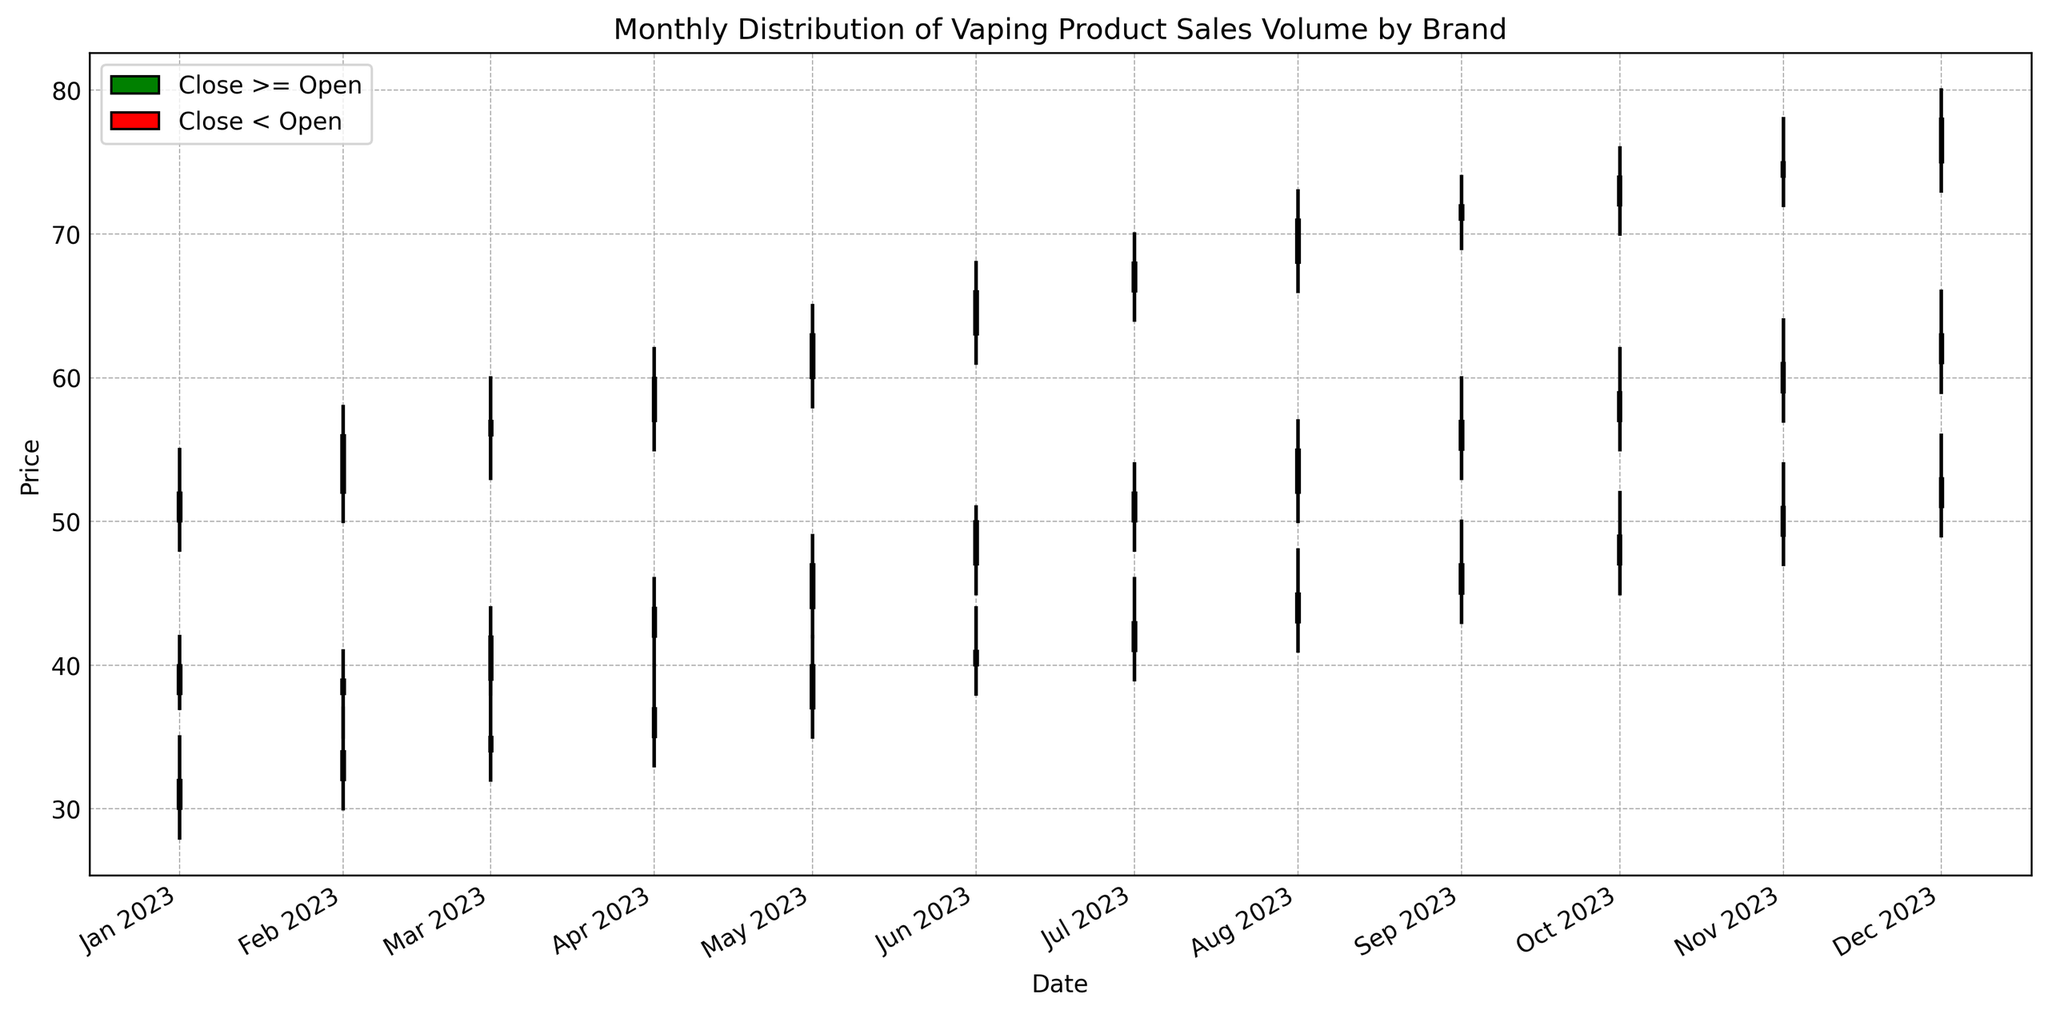What was the highest price achieved by Brand A in August 2023? In the candlestick chart, look for the high point in the candlestick for Brand A in August 2023. It is marked by the top of the wick
Answer: 73 Did Brand B's closing price ever fall and then rise again within the same month? To answer this, observe the color of the candlestick; if it is green, the closing price is higher than the opening price; if it is red, the closing price is lower. Brand B's candles are consistently green or red within each month, indicating no such fluctuations.
Answer: No Which brand saw the most consistent rise in their closing prices over the months? Consider the monthly closing prices of each brand and see which consistently increases. Brand A has a rising trend in closing prices each month throughout the year.
Answer: Brand A During which month did Brand C see the largest increase in their closing price from the previous month? By checking the difference in closing prices of Brand C across consecutive months, the largest increase is from 47 (May 2023) to 50 (June 2023).
Answer: June 2023 How many times did Brand B's closing price remain the same as its opening price? For the closing price to equal the opening price, the candle must be a horizontal line (neither green nor red). This does not visually occur for Brand B in any month.
Answer: 0 times Which brand had the highest sales volume in November 2023? By inspecting the text with the candlestick data, Brand A had the highest sales volume of 2500 in November 2023.
Answer: Brand A Compare the average closing price of Brand C from January to June 2023. Sum the closing prices from January to June for Brand C, which are (38 + 39 + 42 + 44 + 47 + 50) = 260, and divide by 6 months.
Answer: 43.33 Was there a month where all three brands had green candles? Green candles indicate higher closing than opening. Check each month, and in September 2023, all Brand A, Brand B, and Brand C have green candles.
Answer: September 2023 What trend do you observe in the sales volume of Brand A over the year? From January to December, the sales volume of Brand A shows a consistent increase from 1500 in January to 2600 in December.
Answer: Increasing 